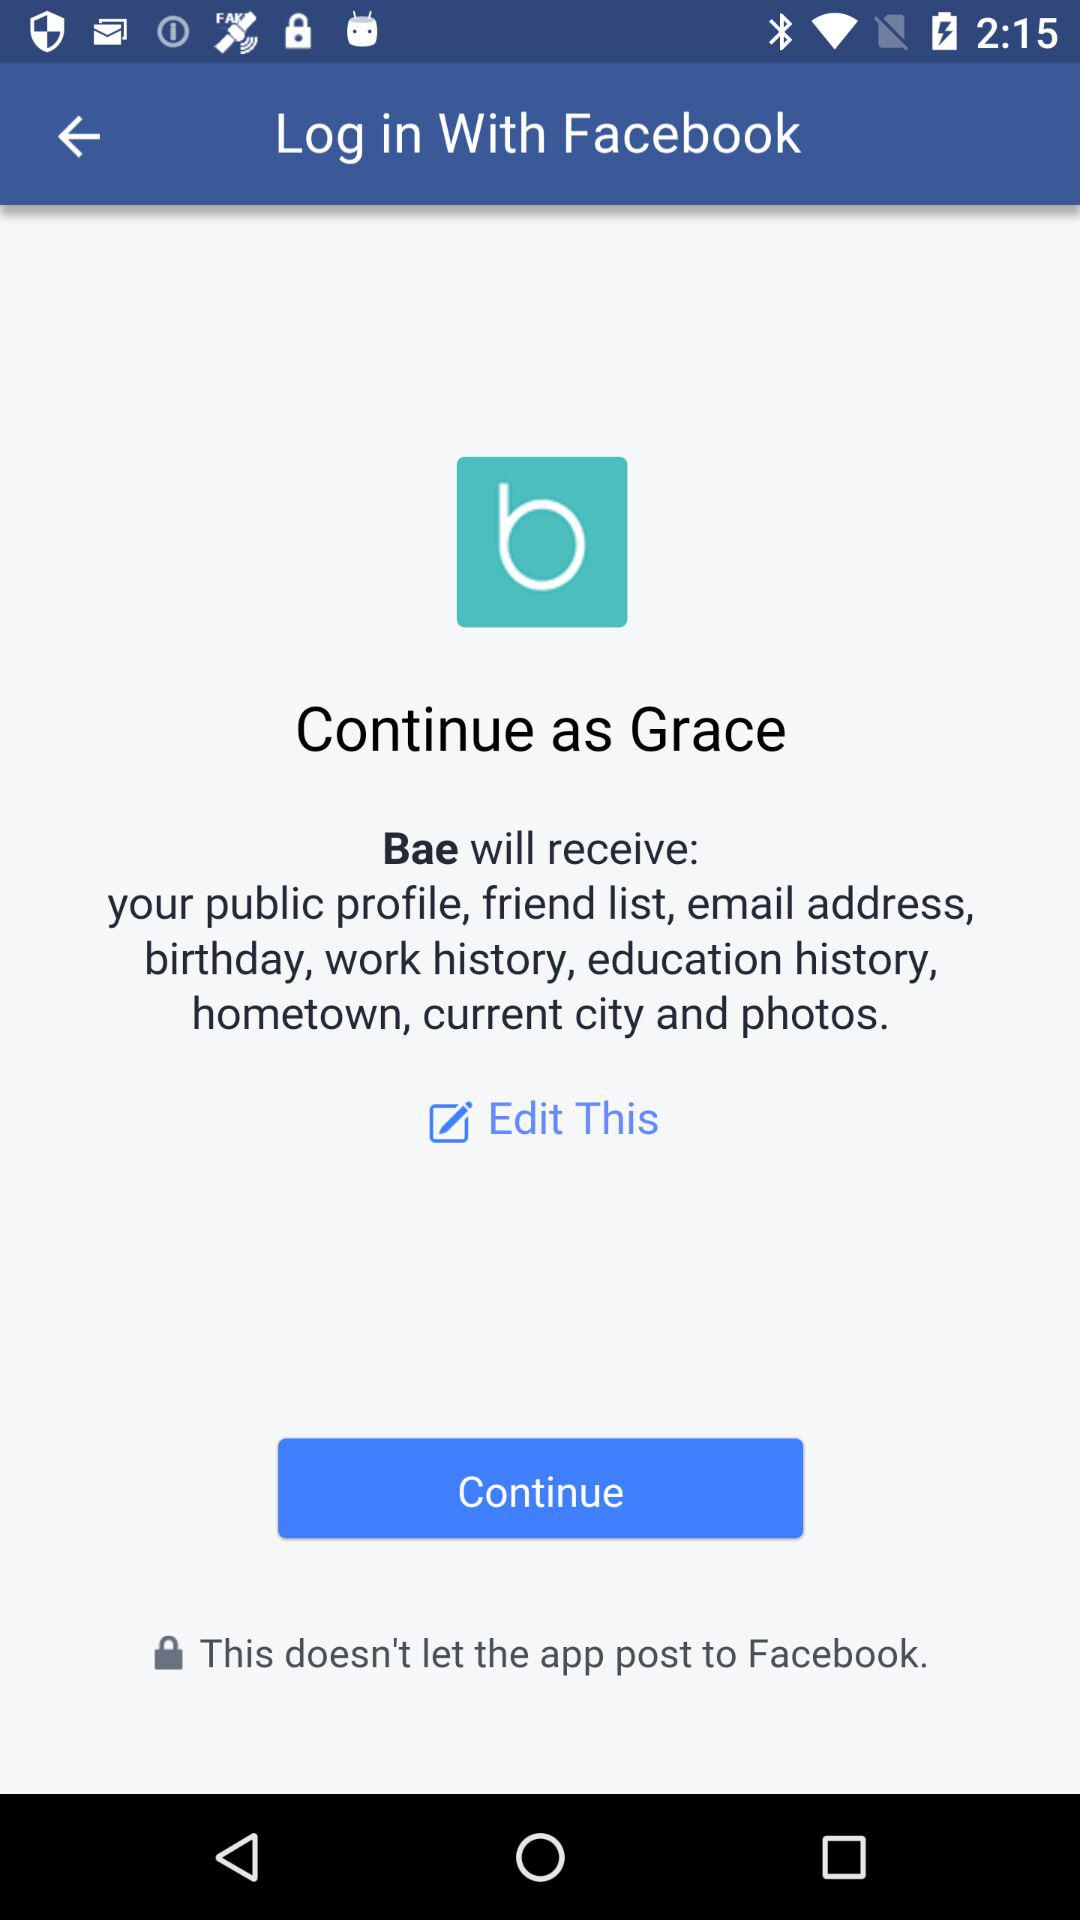What is the user name? The user name is Grace. 